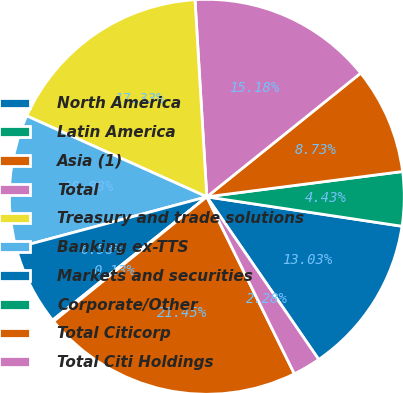Convert chart to OTSL. <chart><loc_0><loc_0><loc_500><loc_500><pie_chart><fcel>North America<fcel>Latin America<fcel>Asia (1)<fcel>Total<fcel>Treasury and trade solutions<fcel>Banking ex-TTS<fcel>Markets and securities<fcel>Corporate/Other<fcel>Total Citicorp<fcel>Total Citi Holdings<nl><fcel>13.03%<fcel>4.43%<fcel>8.73%<fcel>15.18%<fcel>17.33%<fcel>10.88%<fcel>6.58%<fcel>0.13%<fcel>21.45%<fcel>2.28%<nl></chart> 